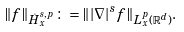<formula> <loc_0><loc_0><loc_500><loc_500>\| f \| _ { \dot { H } _ { x } ^ { s , p } } \colon = \| | \nabla | ^ { s } f \| _ { L _ { x } ^ { p } ( \mathbb { R } ^ { d } ) } .</formula> 